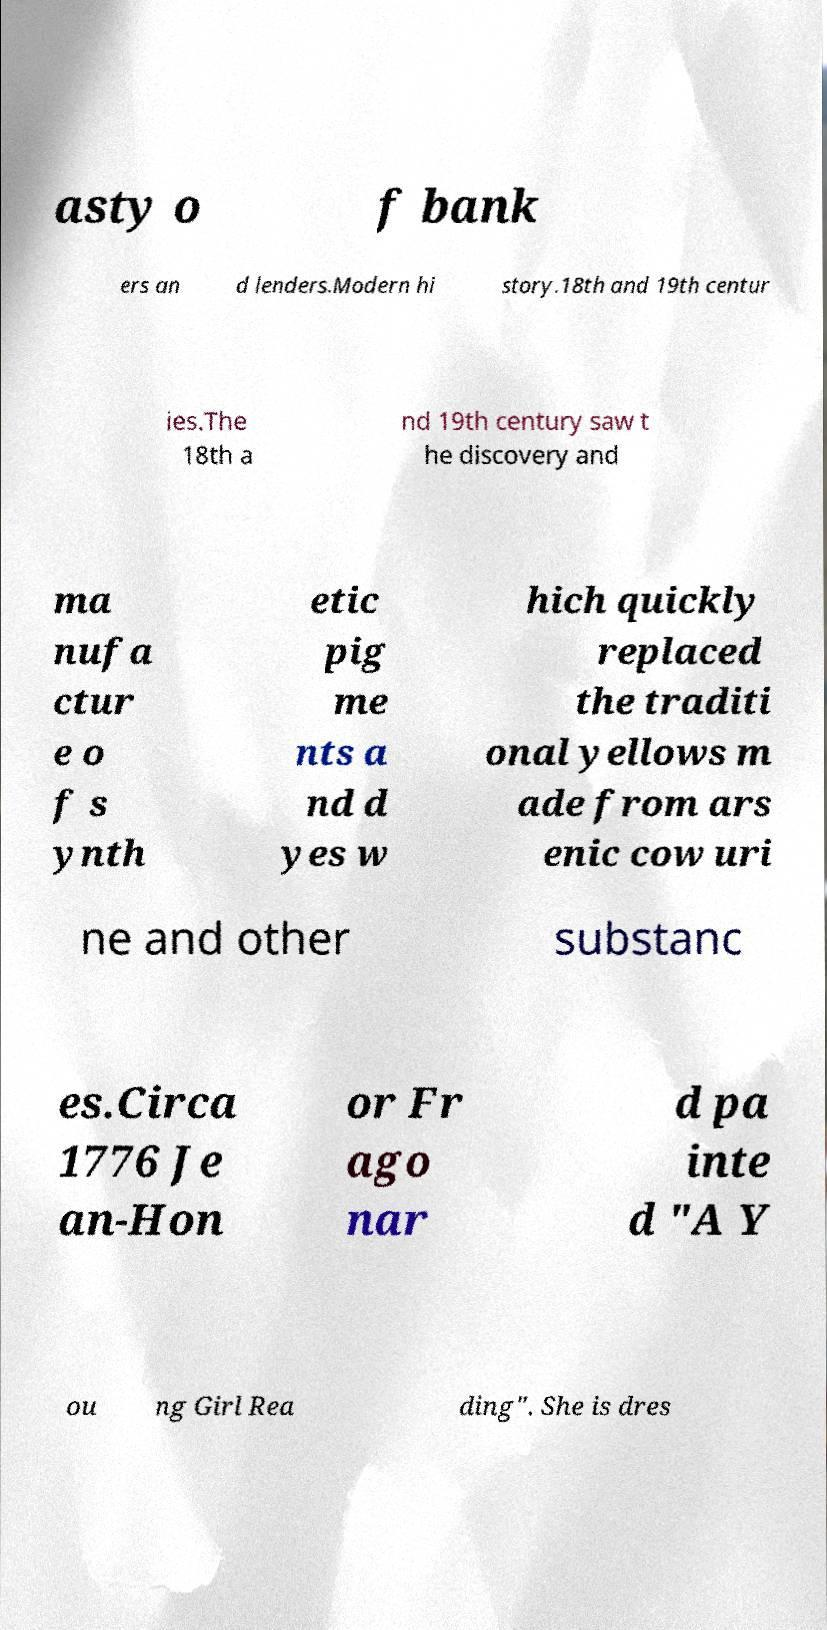Please identify and transcribe the text found in this image. asty o f bank ers an d lenders.Modern hi story.18th and 19th centur ies.The 18th a nd 19th century saw t he discovery and ma nufa ctur e o f s ynth etic pig me nts a nd d yes w hich quickly replaced the traditi onal yellows m ade from ars enic cow uri ne and other substanc es.Circa 1776 Je an-Hon or Fr ago nar d pa inte d "A Y ou ng Girl Rea ding". She is dres 